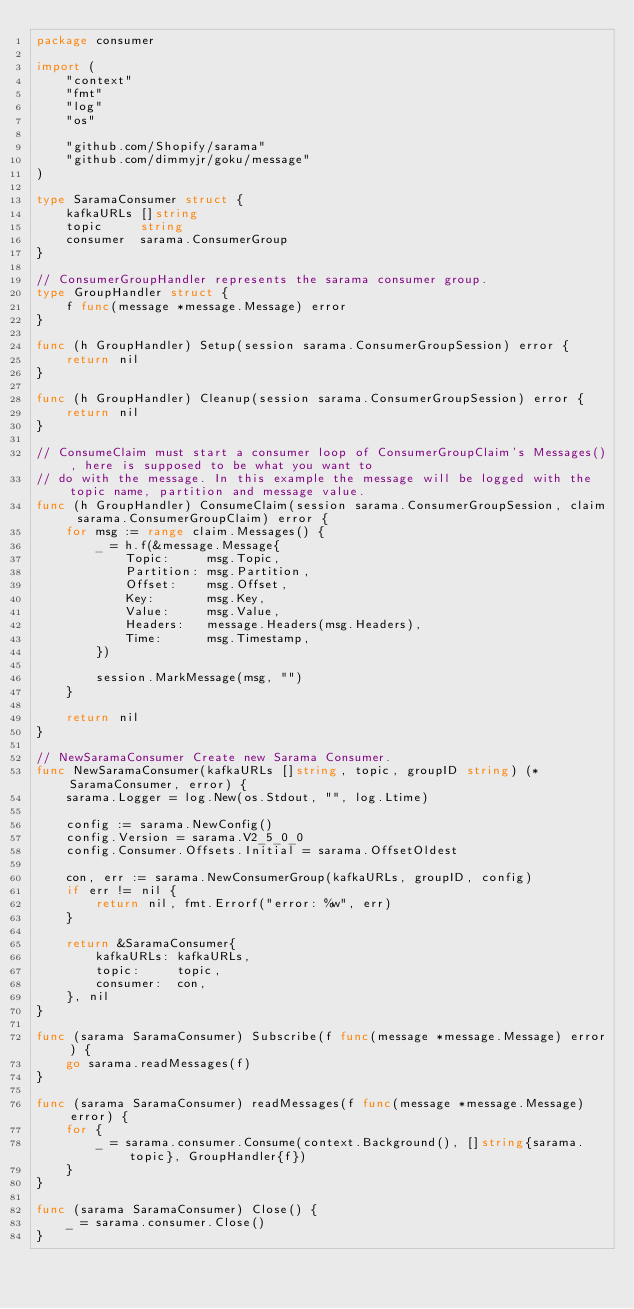<code> <loc_0><loc_0><loc_500><loc_500><_Go_>package consumer

import (
	"context"
	"fmt"
	"log"
	"os"

	"github.com/Shopify/sarama"
	"github.com/dimmyjr/goku/message"
)

type SaramaConsumer struct {
	kafkaURLs []string
	topic     string
	consumer  sarama.ConsumerGroup
}

// ConsumerGroupHandler represents the sarama consumer group.
type GroupHandler struct {
	f func(message *message.Message) error
}

func (h GroupHandler) Setup(session sarama.ConsumerGroupSession) error {
	return nil
}

func (h GroupHandler) Cleanup(session sarama.ConsumerGroupSession) error {
	return nil
}

// ConsumeClaim must start a consumer loop of ConsumerGroupClaim's Messages(), here is supposed to be what you want to
// do with the message. In this example the message will be logged with the topic name, partition and message value.
func (h GroupHandler) ConsumeClaim(session sarama.ConsumerGroupSession, claim sarama.ConsumerGroupClaim) error {
	for msg := range claim.Messages() {
		_ = h.f(&message.Message{
			Topic:     msg.Topic,
			Partition: msg.Partition,
			Offset:    msg.Offset,
			Key:       msg.Key,
			Value:     msg.Value,
			Headers:   message.Headers(msg.Headers),
			Time:      msg.Timestamp,
		})

		session.MarkMessage(msg, "")
	}

	return nil
}

// NewSaramaConsumer Create new Sarama Consumer.
func NewSaramaConsumer(kafkaURLs []string, topic, groupID string) (*SaramaConsumer, error) {
	sarama.Logger = log.New(os.Stdout, "", log.Ltime)

	config := sarama.NewConfig()
	config.Version = sarama.V2_5_0_0
	config.Consumer.Offsets.Initial = sarama.OffsetOldest

	con, err := sarama.NewConsumerGroup(kafkaURLs, groupID, config)
	if err != nil {
		return nil, fmt.Errorf("error: %w", err)
	}

	return &SaramaConsumer{
		kafkaURLs: kafkaURLs,
		topic:     topic,
		consumer:  con,
	}, nil
}

func (sarama SaramaConsumer) Subscribe(f func(message *message.Message) error) {
	go sarama.readMessages(f)
}

func (sarama SaramaConsumer) readMessages(f func(message *message.Message) error) {
	for {
		_ = sarama.consumer.Consume(context.Background(), []string{sarama.topic}, GroupHandler{f})
	}
}

func (sarama SaramaConsumer) Close() {
	_ = sarama.consumer.Close()
}
</code> 